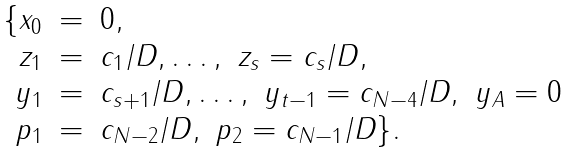Convert formula to latex. <formula><loc_0><loc_0><loc_500><loc_500>\begin{array} { r l l } \{ x _ { 0 } & = & 0 , \\ z _ { 1 } & = & c _ { 1 } / D , \dots , \ z _ { s } = c _ { s } / D , \\ y _ { 1 } & = & c _ { s + 1 } / D , \dots , \ y _ { t - 1 } = c _ { N - 4 } / D , \ y _ { A } = 0 \\ p _ { 1 } & = & c _ { N - 2 } / D , \ p _ { 2 } = c _ { N - 1 } / D \} . \end{array}</formula> 